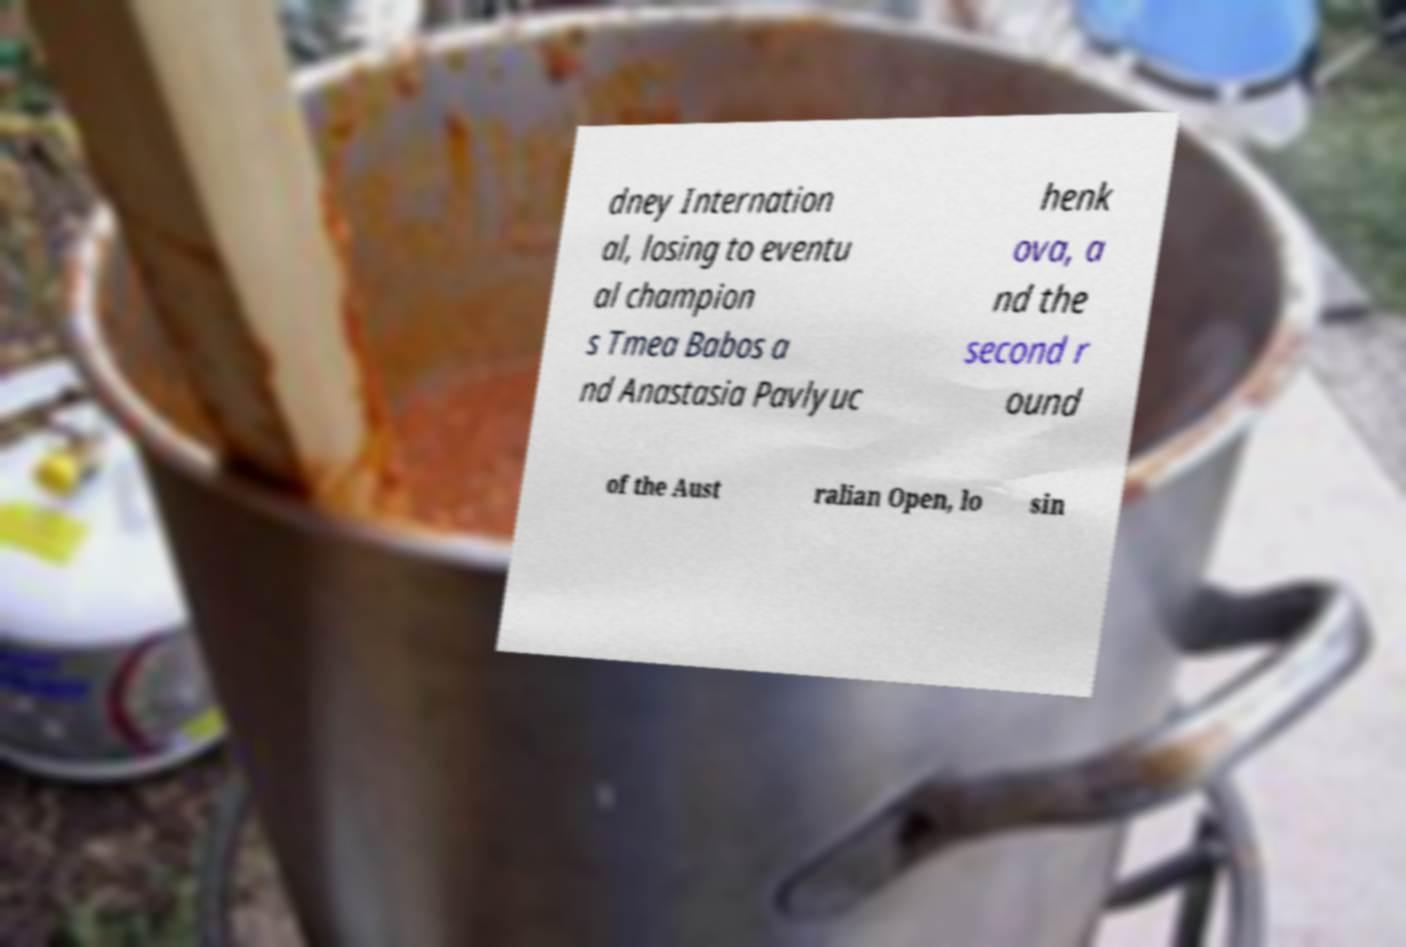I need the written content from this picture converted into text. Can you do that? dney Internation al, losing to eventu al champion s Tmea Babos a nd Anastasia Pavlyuc henk ova, a nd the second r ound of the Aust ralian Open, lo sin 